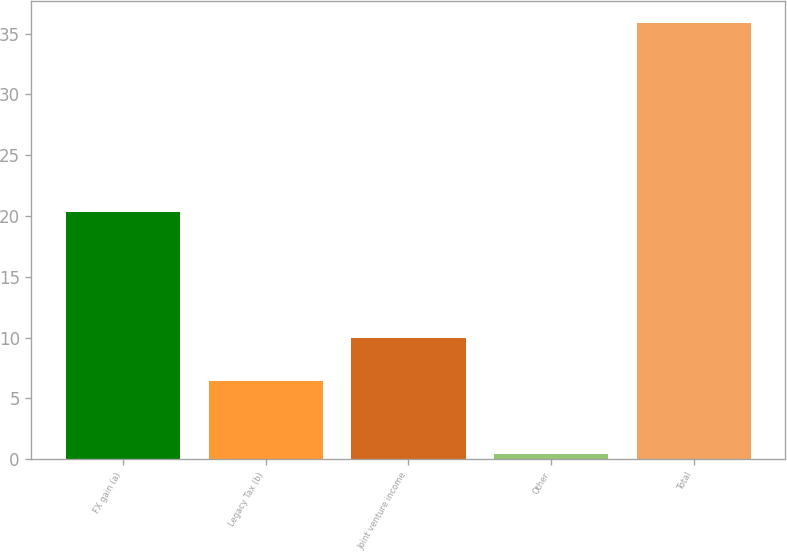Convert chart. <chart><loc_0><loc_0><loc_500><loc_500><bar_chart><fcel>FX gain (a)<fcel>Legacy Tax (b)<fcel>Joint venture income<fcel>Other<fcel>Total<nl><fcel>20.3<fcel>6.4<fcel>9.95<fcel>0.4<fcel>35.9<nl></chart> 